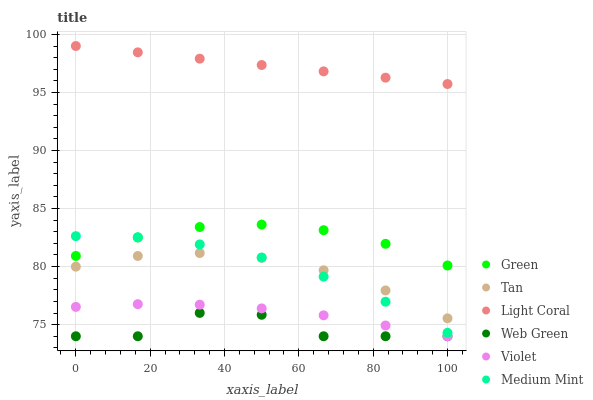Does Web Green have the minimum area under the curve?
Answer yes or no. Yes. Does Light Coral have the maximum area under the curve?
Answer yes or no. Yes. Does Light Coral have the minimum area under the curve?
Answer yes or no. No. Does Web Green have the maximum area under the curve?
Answer yes or no. No. Is Light Coral the smoothest?
Answer yes or no. Yes. Is Web Green the roughest?
Answer yes or no. Yes. Is Web Green the smoothest?
Answer yes or no. No. Is Light Coral the roughest?
Answer yes or no. No. Does Web Green have the lowest value?
Answer yes or no. Yes. Does Light Coral have the lowest value?
Answer yes or no. No. Does Light Coral have the highest value?
Answer yes or no. Yes. Does Web Green have the highest value?
Answer yes or no. No. Is Tan less than Light Coral?
Answer yes or no. Yes. Is Light Coral greater than Green?
Answer yes or no. Yes. Does Web Green intersect Violet?
Answer yes or no. Yes. Is Web Green less than Violet?
Answer yes or no. No. Is Web Green greater than Violet?
Answer yes or no. No. Does Tan intersect Light Coral?
Answer yes or no. No. 